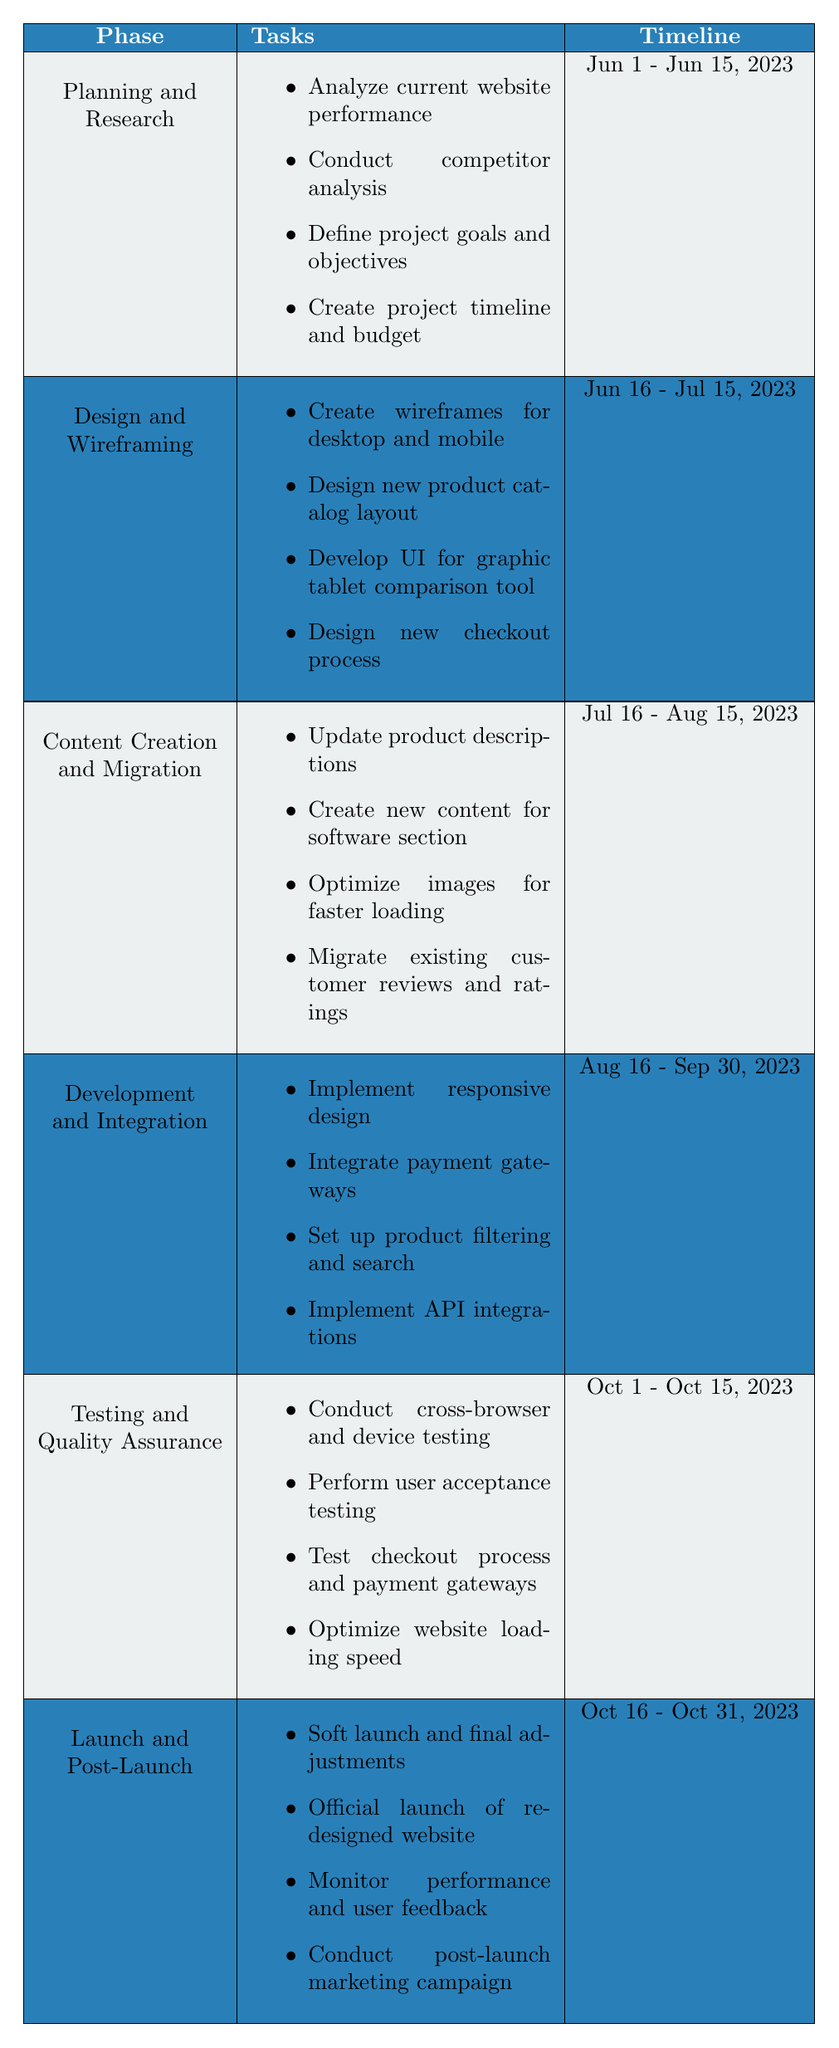What is the duration of the Planning and Research phase? The Planning and Research phase starts on June 1, 2023, and ends on June 15, 2023. The duration is calculated as June 15 minus June 1, which is 15 days.
Answer: 15 days Which phase comes after Development and Integration? The phase that follows Development and Integration, which ends on September 30, 2023, is Testing and Quality Assurance, which starts on October 1, 2023.
Answer: Testing and Quality Assurance Is the Design and Wireframing phase longer than the Testing and Quality Assurance phase? The Design and Wireframing phase lasts from June 16, 2023, to July 15, 2023, for a total of 30 days. The Testing and Quality Assurance phase lasts from October 1, 2023, to October 15, 2023, for a total of 15 days. Since 30 days is greater than 15 days, the statement is true.
Answer: Yes How many tasks are involved in the Content Creation and Migration phase? In the Content Creation and Migration phase, there are 4 tasks: updating product descriptions, creating new content for software section, optimizing images, and migrating reviews. So, there are a total of 4 tasks.
Answer: 4 tasks What is the time interval between the end of the Content Creation and Migration phase and the start of Development and Integration? The Content Creation and Migration phase ends on August 15, 2023, and the Development and Integration phase starts on August 16, 2023. The interval is 1 day, from August 15 to August 16.
Answer: 1 day What is the timeline of the entire project from start to finish? The project timeline starts on June 1, 2023, with the Planning and Research phase and ends on October 31, 2023, with the Launch and Post-Launch phase. Thus, the overall project span is from June 1 to October 31.
Answer: June 1 - October 31, 2023 Which phase has the most tasks and what are they? The Development and Integration phase contains 4 tasks: implementing responsive design, integrating payment gateways, setting up product filtering, and implementing API integrations. No other phase has more tasks listed.
Answer: Development and Integration (4 tasks) Are there any tasks related to optimizing website speed in the Testing and Quality Assurance phase? Yes, one of the tasks listed in the Testing and Quality Assurance phase is to optimize website loading speed, which directly relates to improving website performance. Therefore, the answer is true.
Answer: Yes How many days are the Launch and Post-Launch phase scheduled for? The Launch and Post-Launch phase lasts from October 16, 2023, to October 31, 2023. To find the duration, we calculate the difference: October 31 minus October 16 results in 15 days, thus the duration is 15 days.
Answer: 15 days 